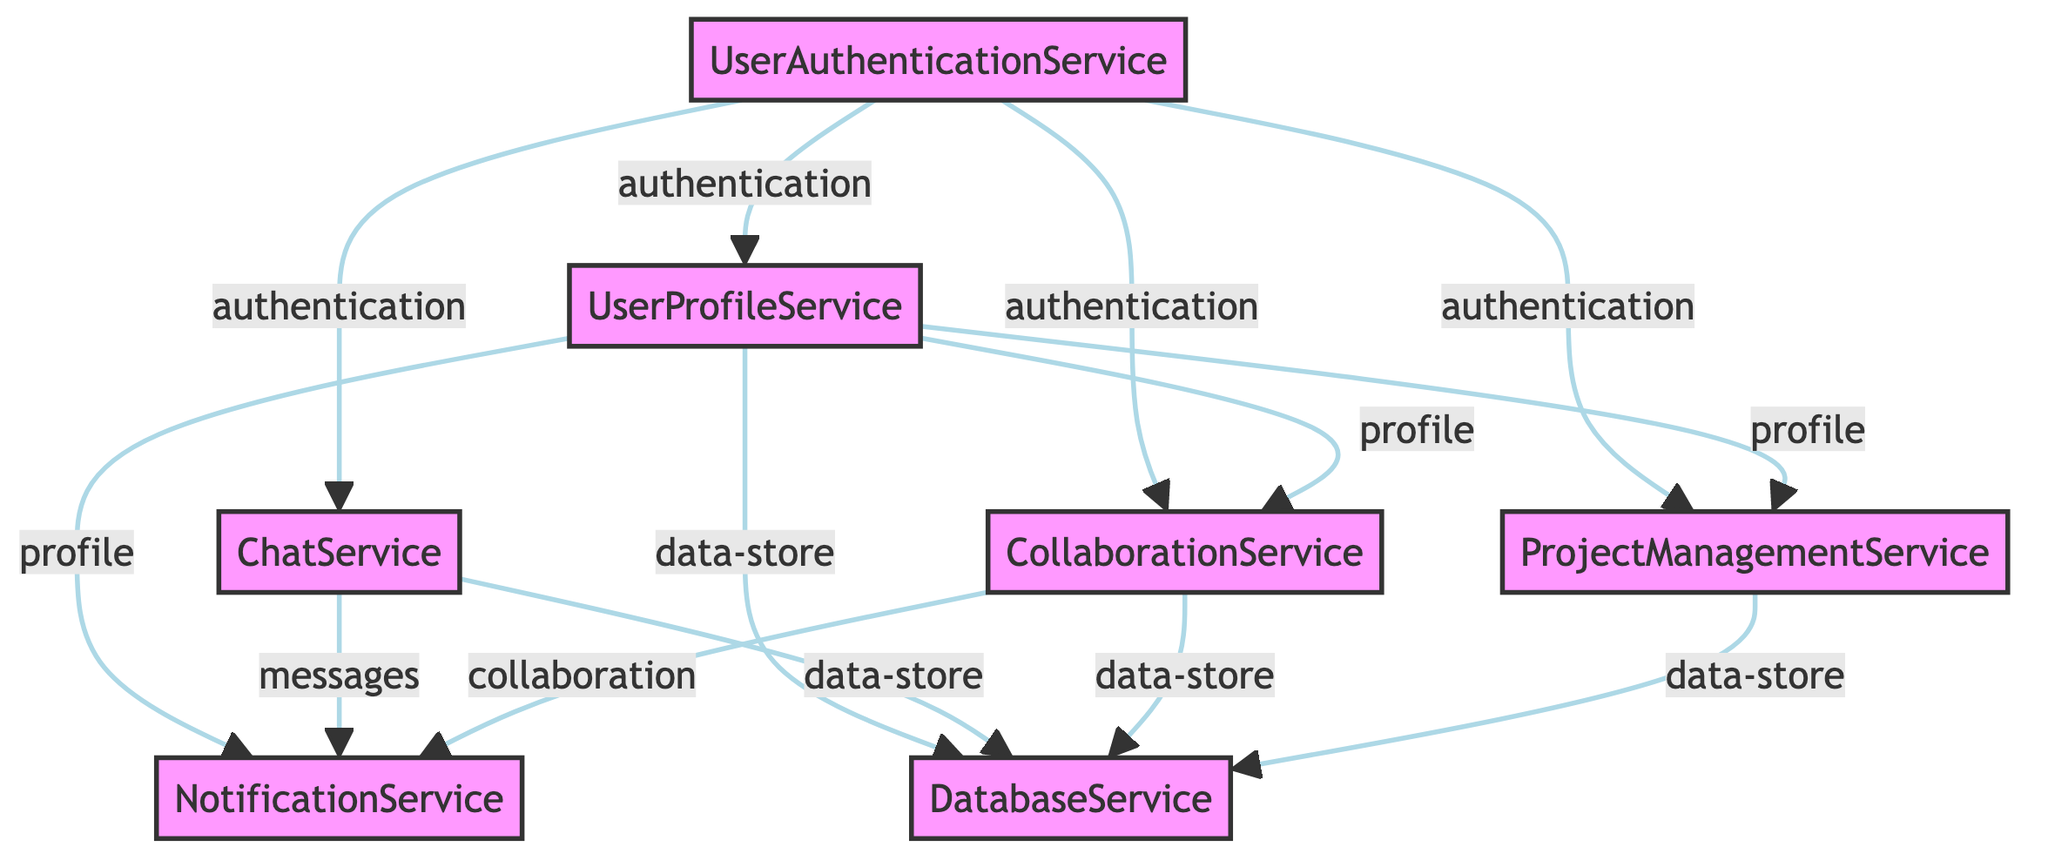What is the number of services in the architecture? The diagram lists seven different services: UserAuthenticationService, UserProfileService, ChatService, CollaborationService, NotificationService, ProjectManagementService, and DatabaseService.
Answer: 7 Which service handles user login and authentication processes? The description of the UserAuthenticationService states it is responsible for handling user login and authentication processes.
Answer: UserAuthenticationService How many dependencies does the NotificationService have? The NotificationService has three dependencies listed: UserProfileService, ChatService, and CollaborationService.
Answer: 3 What type of flow exists from UserProfileService to CollaborationService? The diagram indicates that the flow between UserProfileService and CollaborationService is labeled as profile.
Answer: profile How does the ProjectManagementService communicate with the DatabaseService? The ProjectManagementService communicates with the DatabaseService through a data-store flow type, which signifies interaction for storing project-related data.
Answer: data-store Which service is required by both CollaborationService and ProjectManagementService? The analysis shows that both CollaborationService and ProjectManagementService depend on UserAuthenticationService for their operations.
Answer: UserAuthenticationService What is the primary role of the DatabaseService in the architecture? The DatabaseService serves as the central storage for all user data, chats, and project details, indicating its role as the main data repository.
Answer: Central storage How many authentication flows are directed from UserAuthenticationService? The UserAuthenticationService has four outgoing flows labeled as authentication to UserProfileService, ChatService, CollaborationService, and ProjectManagementService, totaling four flows.
Answer: 4 Which service sends messages to the NotificationService? It is evident from the diagram that the ChatService sends messages to the NotificationService, as indicated by the labeled flow.
Answer: ChatService 